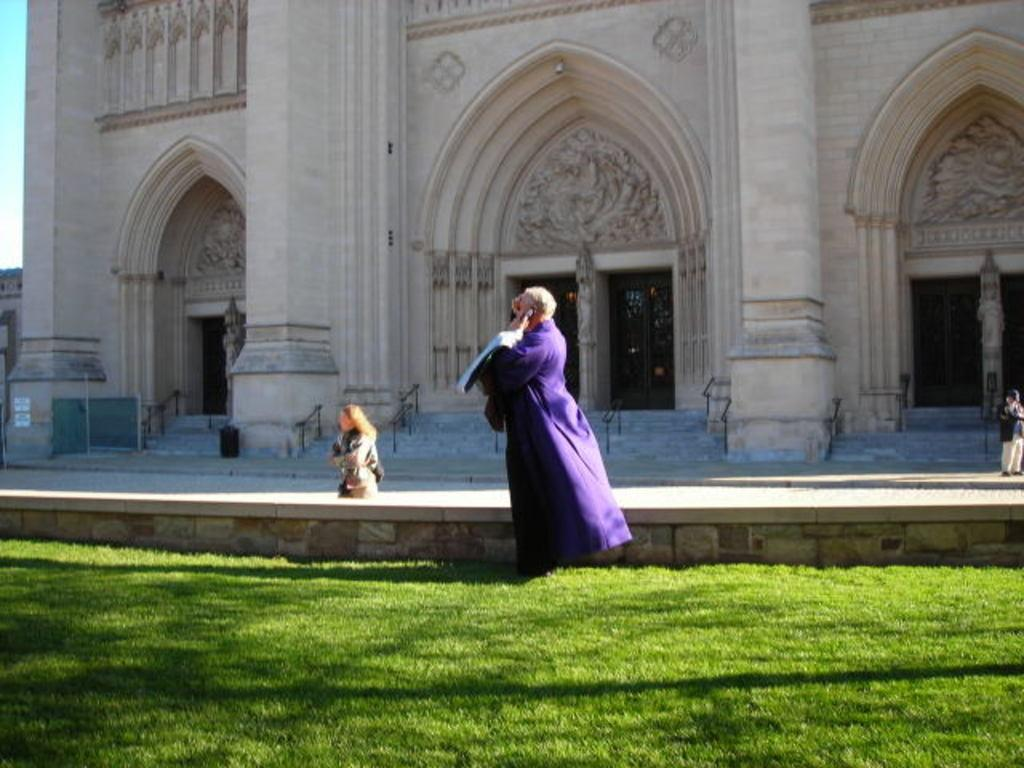What type of vegetation covers the land in the image? The land is covered with grass. What can be seen behind the people in the image? There are people in front of a building. How many doors are visible in the image? There are doors visible in the image. Can you see any tigers walking on the grass in the image? There are no tigers visible in the image; it features people in front of a building on a grass-covered land. 